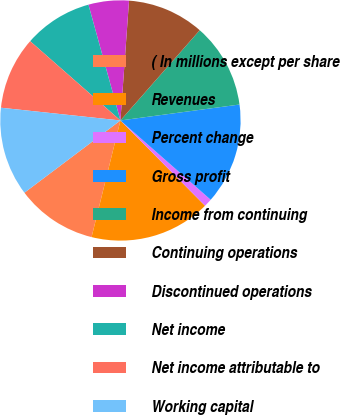Convert chart. <chart><loc_0><loc_0><loc_500><loc_500><pie_chart><fcel>( In millions except per share<fcel>Revenues<fcel>Percent change<fcel>Gross profit<fcel>Income from continuing<fcel>Continuing operations<fcel>Discontinued operations<fcel>Net income<fcel>Net income attributable to<fcel>Working capital<nl><fcel>10.87%<fcel>16.3%<fcel>1.09%<fcel>13.59%<fcel>11.41%<fcel>10.33%<fcel>5.43%<fcel>9.24%<fcel>9.78%<fcel>11.96%<nl></chart> 